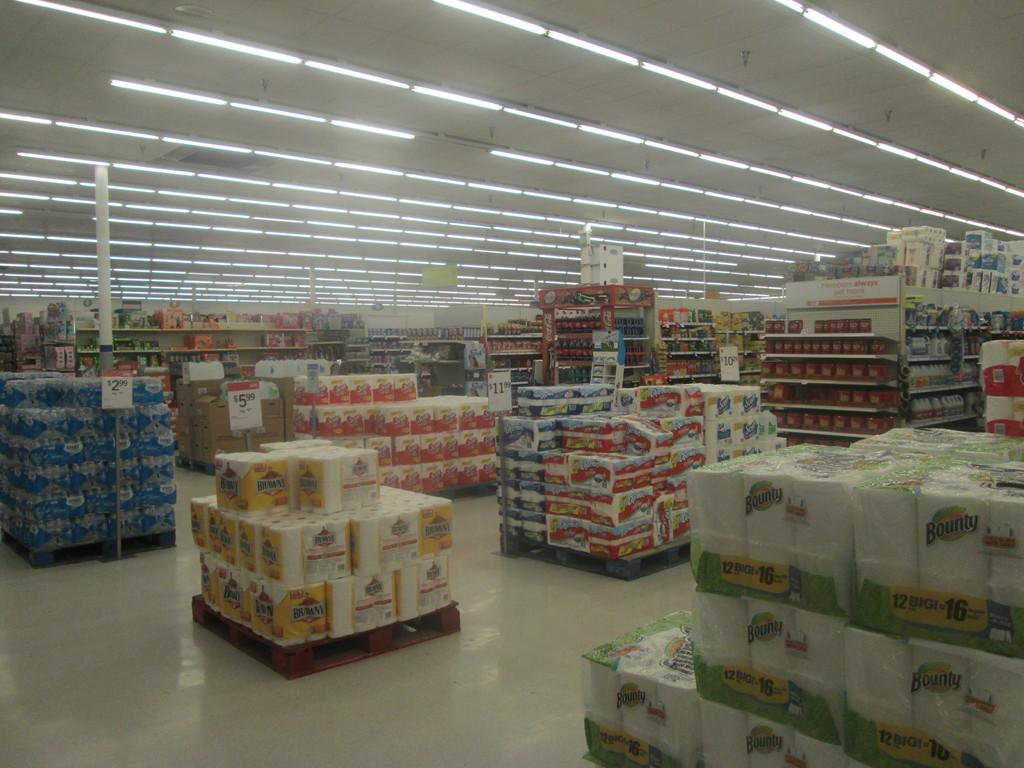<image>
Create a compact narrative representing the image presented. The grocery store has Bounty and Brawny paper towels on display. 